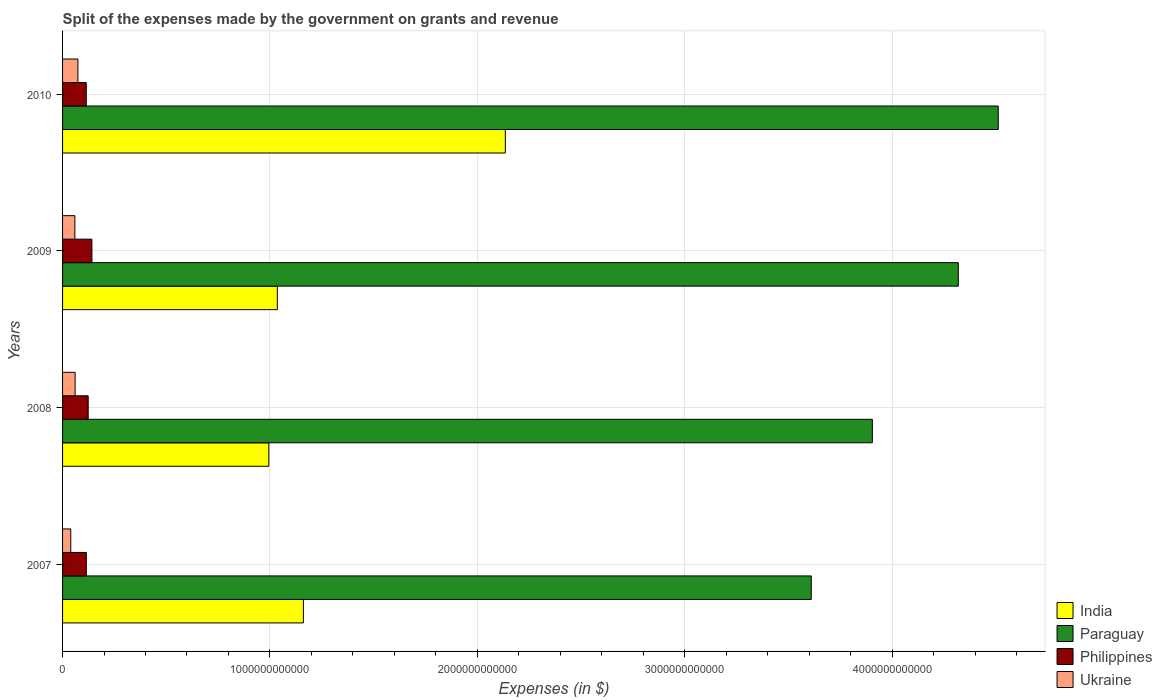How many different coloured bars are there?
Offer a terse response. 4. How many groups of bars are there?
Offer a terse response. 4. Are the number of bars on each tick of the Y-axis equal?
Your response must be concise. Yes. How many bars are there on the 2nd tick from the bottom?
Your answer should be very brief. 4. What is the expenses made by the government on grants and revenue in Paraguay in 2007?
Ensure brevity in your answer.  3.61e+12. Across all years, what is the maximum expenses made by the government on grants and revenue in Philippines?
Your response must be concise. 1.42e+11. Across all years, what is the minimum expenses made by the government on grants and revenue in Paraguay?
Give a very brief answer. 3.61e+12. What is the total expenses made by the government on grants and revenue in Paraguay in the graph?
Your response must be concise. 1.63e+13. What is the difference between the expenses made by the government on grants and revenue in Paraguay in 2007 and that in 2010?
Provide a succinct answer. -9.02e+11. What is the difference between the expenses made by the government on grants and revenue in Paraguay in 2009 and the expenses made by the government on grants and revenue in Ukraine in 2008?
Provide a succinct answer. 4.26e+12. What is the average expenses made by the government on grants and revenue in Philippines per year?
Offer a terse response. 1.23e+11. In the year 2008, what is the difference between the expenses made by the government on grants and revenue in Philippines and expenses made by the government on grants and revenue in Ukraine?
Your answer should be very brief. 6.30e+1. In how many years, is the expenses made by the government on grants and revenue in India greater than 1400000000000 $?
Your answer should be very brief. 1. What is the ratio of the expenses made by the government on grants and revenue in Ukraine in 2007 to that in 2009?
Your answer should be compact. 0.67. Is the difference between the expenses made by the government on grants and revenue in Philippines in 2007 and 2010 greater than the difference between the expenses made by the government on grants and revenue in Ukraine in 2007 and 2010?
Ensure brevity in your answer.  Yes. What is the difference between the highest and the second highest expenses made by the government on grants and revenue in Paraguay?
Give a very brief answer. 1.93e+11. What is the difference between the highest and the lowest expenses made by the government on grants and revenue in Paraguay?
Offer a terse response. 9.02e+11. Is it the case that in every year, the sum of the expenses made by the government on grants and revenue in Paraguay and expenses made by the government on grants and revenue in Ukraine is greater than the sum of expenses made by the government on grants and revenue in India and expenses made by the government on grants and revenue in Philippines?
Ensure brevity in your answer.  Yes. What does the 4th bar from the bottom in 2007 represents?
Your answer should be compact. Ukraine. Are all the bars in the graph horizontal?
Provide a short and direct response. Yes. How many years are there in the graph?
Ensure brevity in your answer.  4. What is the difference between two consecutive major ticks on the X-axis?
Offer a terse response. 1.00e+12. Are the values on the major ticks of X-axis written in scientific E-notation?
Your answer should be very brief. No. Does the graph contain any zero values?
Provide a succinct answer. No. Does the graph contain grids?
Give a very brief answer. Yes. Where does the legend appear in the graph?
Provide a succinct answer. Bottom right. How many legend labels are there?
Ensure brevity in your answer.  4. How are the legend labels stacked?
Offer a terse response. Vertical. What is the title of the graph?
Your answer should be very brief. Split of the expenses made by the government on grants and revenue. What is the label or title of the X-axis?
Provide a short and direct response. Expenses (in $). What is the Expenses (in $) in India in 2007?
Your answer should be very brief. 1.16e+12. What is the Expenses (in $) in Paraguay in 2007?
Give a very brief answer. 3.61e+12. What is the Expenses (in $) of Philippines in 2007?
Your answer should be very brief. 1.15e+11. What is the Expenses (in $) of Ukraine in 2007?
Your response must be concise. 3.95e+1. What is the Expenses (in $) in India in 2008?
Offer a very short reply. 9.95e+11. What is the Expenses (in $) of Paraguay in 2008?
Your answer should be very brief. 3.91e+12. What is the Expenses (in $) in Philippines in 2008?
Your response must be concise. 1.24e+11. What is the Expenses (in $) of Ukraine in 2008?
Offer a terse response. 6.05e+1. What is the Expenses (in $) of India in 2009?
Give a very brief answer. 1.04e+12. What is the Expenses (in $) in Paraguay in 2009?
Your answer should be compact. 4.32e+12. What is the Expenses (in $) of Philippines in 2009?
Offer a very short reply. 1.42e+11. What is the Expenses (in $) of Ukraine in 2009?
Provide a succinct answer. 5.94e+1. What is the Expenses (in $) of India in 2010?
Provide a short and direct response. 2.14e+12. What is the Expenses (in $) in Paraguay in 2010?
Your answer should be compact. 4.51e+12. What is the Expenses (in $) in Philippines in 2010?
Your answer should be compact. 1.14e+11. What is the Expenses (in $) of Ukraine in 2010?
Your answer should be compact. 7.40e+1. Across all years, what is the maximum Expenses (in $) in India?
Your answer should be very brief. 2.14e+12. Across all years, what is the maximum Expenses (in $) in Paraguay?
Give a very brief answer. 4.51e+12. Across all years, what is the maximum Expenses (in $) in Philippines?
Offer a terse response. 1.42e+11. Across all years, what is the maximum Expenses (in $) in Ukraine?
Your answer should be very brief. 7.40e+1. Across all years, what is the minimum Expenses (in $) in India?
Make the answer very short. 9.95e+11. Across all years, what is the minimum Expenses (in $) in Paraguay?
Give a very brief answer. 3.61e+12. Across all years, what is the minimum Expenses (in $) of Philippines?
Make the answer very short. 1.14e+11. Across all years, what is the minimum Expenses (in $) in Ukraine?
Ensure brevity in your answer.  3.95e+1. What is the total Expenses (in $) in India in the graph?
Your answer should be compact. 5.33e+12. What is the total Expenses (in $) in Paraguay in the graph?
Your answer should be very brief. 1.63e+13. What is the total Expenses (in $) of Philippines in the graph?
Offer a terse response. 4.94e+11. What is the total Expenses (in $) of Ukraine in the graph?
Your answer should be very brief. 2.33e+11. What is the difference between the Expenses (in $) of India in 2007 and that in 2008?
Your answer should be compact. 1.67e+11. What is the difference between the Expenses (in $) in Paraguay in 2007 and that in 2008?
Give a very brief answer. -2.95e+11. What is the difference between the Expenses (in $) of Philippines in 2007 and that in 2008?
Give a very brief answer. -9.00e+09. What is the difference between the Expenses (in $) in Ukraine in 2007 and that in 2008?
Give a very brief answer. -2.10e+1. What is the difference between the Expenses (in $) in India in 2007 and that in 2009?
Give a very brief answer. 1.26e+11. What is the difference between the Expenses (in $) in Paraguay in 2007 and that in 2009?
Your answer should be very brief. -7.09e+11. What is the difference between the Expenses (in $) in Philippines in 2007 and that in 2009?
Give a very brief answer. -2.69e+1. What is the difference between the Expenses (in $) of Ukraine in 2007 and that in 2009?
Keep it short and to the point. -1.98e+1. What is the difference between the Expenses (in $) in India in 2007 and that in 2010?
Provide a succinct answer. -9.74e+11. What is the difference between the Expenses (in $) in Paraguay in 2007 and that in 2010?
Ensure brevity in your answer.  -9.02e+11. What is the difference between the Expenses (in $) of Philippines in 2007 and that in 2010?
Give a very brief answer. 2.58e+08. What is the difference between the Expenses (in $) of Ukraine in 2007 and that in 2010?
Offer a very short reply. -3.45e+1. What is the difference between the Expenses (in $) in India in 2008 and that in 2009?
Offer a terse response. -4.10e+1. What is the difference between the Expenses (in $) in Paraguay in 2008 and that in 2009?
Your answer should be very brief. -4.14e+11. What is the difference between the Expenses (in $) of Philippines in 2008 and that in 2009?
Your answer should be very brief. -1.79e+1. What is the difference between the Expenses (in $) in Ukraine in 2008 and that in 2009?
Provide a succinct answer. 1.17e+09. What is the difference between the Expenses (in $) in India in 2008 and that in 2010?
Provide a short and direct response. -1.14e+12. What is the difference between the Expenses (in $) of Paraguay in 2008 and that in 2010?
Your answer should be compact. -6.07e+11. What is the difference between the Expenses (in $) of Philippines in 2008 and that in 2010?
Offer a terse response. 9.26e+09. What is the difference between the Expenses (in $) in Ukraine in 2008 and that in 2010?
Make the answer very short. -1.35e+1. What is the difference between the Expenses (in $) in India in 2009 and that in 2010?
Offer a terse response. -1.10e+12. What is the difference between the Expenses (in $) in Paraguay in 2009 and that in 2010?
Make the answer very short. -1.93e+11. What is the difference between the Expenses (in $) in Philippines in 2009 and that in 2010?
Provide a succinct answer. 2.72e+1. What is the difference between the Expenses (in $) of Ukraine in 2009 and that in 2010?
Ensure brevity in your answer.  -1.47e+1. What is the difference between the Expenses (in $) of India in 2007 and the Expenses (in $) of Paraguay in 2008?
Make the answer very short. -2.74e+12. What is the difference between the Expenses (in $) of India in 2007 and the Expenses (in $) of Philippines in 2008?
Your answer should be compact. 1.04e+12. What is the difference between the Expenses (in $) in India in 2007 and the Expenses (in $) in Ukraine in 2008?
Provide a succinct answer. 1.10e+12. What is the difference between the Expenses (in $) in Paraguay in 2007 and the Expenses (in $) in Philippines in 2008?
Provide a short and direct response. 3.49e+12. What is the difference between the Expenses (in $) in Paraguay in 2007 and the Expenses (in $) in Ukraine in 2008?
Your response must be concise. 3.55e+12. What is the difference between the Expenses (in $) of Philippines in 2007 and the Expenses (in $) of Ukraine in 2008?
Make the answer very short. 5.40e+1. What is the difference between the Expenses (in $) in India in 2007 and the Expenses (in $) in Paraguay in 2009?
Make the answer very short. -3.16e+12. What is the difference between the Expenses (in $) in India in 2007 and the Expenses (in $) in Philippines in 2009?
Offer a terse response. 1.02e+12. What is the difference between the Expenses (in $) in India in 2007 and the Expenses (in $) in Ukraine in 2009?
Ensure brevity in your answer.  1.10e+12. What is the difference between the Expenses (in $) of Paraguay in 2007 and the Expenses (in $) of Philippines in 2009?
Your answer should be compact. 3.47e+12. What is the difference between the Expenses (in $) of Paraguay in 2007 and the Expenses (in $) of Ukraine in 2009?
Your answer should be compact. 3.55e+12. What is the difference between the Expenses (in $) of Philippines in 2007 and the Expenses (in $) of Ukraine in 2009?
Your answer should be compact. 5.52e+1. What is the difference between the Expenses (in $) of India in 2007 and the Expenses (in $) of Paraguay in 2010?
Make the answer very short. -3.35e+12. What is the difference between the Expenses (in $) of India in 2007 and the Expenses (in $) of Philippines in 2010?
Keep it short and to the point. 1.05e+12. What is the difference between the Expenses (in $) in India in 2007 and the Expenses (in $) in Ukraine in 2010?
Your response must be concise. 1.09e+12. What is the difference between the Expenses (in $) of Paraguay in 2007 and the Expenses (in $) of Philippines in 2010?
Give a very brief answer. 3.50e+12. What is the difference between the Expenses (in $) of Paraguay in 2007 and the Expenses (in $) of Ukraine in 2010?
Your answer should be very brief. 3.54e+12. What is the difference between the Expenses (in $) of Philippines in 2007 and the Expenses (in $) of Ukraine in 2010?
Your answer should be compact. 4.05e+1. What is the difference between the Expenses (in $) of India in 2008 and the Expenses (in $) of Paraguay in 2009?
Ensure brevity in your answer.  -3.32e+12. What is the difference between the Expenses (in $) in India in 2008 and the Expenses (in $) in Philippines in 2009?
Your answer should be compact. 8.53e+11. What is the difference between the Expenses (in $) of India in 2008 and the Expenses (in $) of Ukraine in 2009?
Your answer should be compact. 9.35e+11. What is the difference between the Expenses (in $) of Paraguay in 2008 and the Expenses (in $) of Philippines in 2009?
Offer a terse response. 3.76e+12. What is the difference between the Expenses (in $) in Paraguay in 2008 and the Expenses (in $) in Ukraine in 2009?
Provide a short and direct response. 3.85e+12. What is the difference between the Expenses (in $) of Philippines in 2008 and the Expenses (in $) of Ukraine in 2009?
Your answer should be compact. 6.42e+1. What is the difference between the Expenses (in $) of India in 2008 and the Expenses (in $) of Paraguay in 2010?
Keep it short and to the point. -3.52e+12. What is the difference between the Expenses (in $) in India in 2008 and the Expenses (in $) in Philippines in 2010?
Ensure brevity in your answer.  8.80e+11. What is the difference between the Expenses (in $) of India in 2008 and the Expenses (in $) of Ukraine in 2010?
Keep it short and to the point. 9.21e+11. What is the difference between the Expenses (in $) of Paraguay in 2008 and the Expenses (in $) of Philippines in 2010?
Your answer should be compact. 3.79e+12. What is the difference between the Expenses (in $) of Paraguay in 2008 and the Expenses (in $) of Ukraine in 2010?
Make the answer very short. 3.83e+12. What is the difference between the Expenses (in $) in Philippines in 2008 and the Expenses (in $) in Ukraine in 2010?
Offer a terse response. 4.95e+1. What is the difference between the Expenses (in $) of India in 2009 and the Expenses (in $) of Paraguay in 2010?
Provide a short and direct response. -3.48e+12. What is the difference between the Expenses (in $) of India in 2009 and the Expenses (in $) of Philippines in 2010?
Give a very brief answer. 9.21e+11. What is the difference between the Expenses (in $) in India in 2009 and the Expenses (in $) in Ukraine in 2010?
Provide a succinct answer. 9.62e+11. What is the difference between the Expenses (in $) in Paraguay in 2009 and the Expenses (in $) in Philippines in 2010?
Your answer should be compact. 4.21e+12. What is the difference between the Expenses (in $) of Paraguay in 2009 and the Expenses (in $) of Ukraine in 2010?
Provide a succinct answer. 4.25e+12. What is the difference between the Expenses (in $) of Philippines in 2009 and the Expenses (in $) of Ukraine in 2010?
Give a very brief answer. 6.75e+1. What is the average Expenses (in $) of India per year?
Offer a very short reply. 1.33e+12. What is the average Expenses (in $) of Paraguay per year?
Offer a terse response. 4.09e+12. What is the average Expenses (in $) of Philippines per year?
Provide a succinct answer. 1.23e+11. What is the average Expenses (in $) of Ukraine per year?
Give a very brief answer. 5.84e+1. In the year 2007, what is the difference between the Expenses (in $) of India and Expenses (in $) of Paraguay?
Keep it short and to the point. -2.45e+12. In the year 2007, what is the difference between the Expenses (in $) of India and Expenses (in $) of Philippines?
Ensure brevity in your answer.  1.05e+12. In the year 2007, what is the difference between the Expenses (in $) in India and Expenses (in $) in Ukraine?
Make the answer very short. 1.12e+12. In the year 2007, what is the difference between the Expenses (in $) of Paraguay and Expenses (in $) of Philippines?
Offer a terse response. 3.50e+12. In the year 2007, what is the difference between the Expenses (in $) of Paraguay and Expenses (in $) of Ukraine?
Provide a succinct answer. 3.57e+12. In the year 2007, what is the difference between the Expenses (in $) in Philippines and Expenses (in $) in Ukraine?
Your answer should be compact. 7.50e+1. In the year 2008, what is the difference between the Expenses (in $) in India and Expenses (in $) in Paraguay?
Give a very brief answer. -2.91e+12. In the year 2008, what is the difference between the Expenses (in $) of India and Expenses (in $) of Philippines?
Make the answer very short. 8.71e+11. In the year 2008, what is the difference between the Expenses (in $) of India and Expenses (in $) of Ukraine?
Your response must be concise. 9.34e+11. In the year 2008, what is the difference between the Expenses (in $) of Paraguay and Expenses (in $) of Philippines?
Ensure brevity in your answer.  3.78e+12. In the year 2008, what is the difference between the Expenses (in $) of Paraguay and Expenses (in $) of Ukraine?
Your answer should be compact. 3.84e+12. In the year 2008, what is the difference between the Expenses (in $) in Philippines and Expenses (in $) in Ukraine?
Give a very brief answer. 6.30e+1. In the year 2009, what is the difference between the Expenses (in $) of India and Expenses (in $) of Paraguay?
Offer a terse response. -3.28e+12. In the year 2009, what is the difference between the Expenses (in $) in India and Expenses (in $) in Philippines?
Your response must be concise. 8.94e+11. In the year 2009, what is the difference between the Expenses (in $) of India and Expenses (in $) of Ukraine?
Provide a short and direct response. 9.76e+11. In the year 2009, what is the difference between the Expenses (in $) in Paraguay and Expenses (in $) in Philippines?
Make the answer very short. 4.18e+12. In the year 2009, what is the difference between the Expenses (in $) of Paraguay and Expenses (in $) of Ukraine?
Offer a terse response. 4.26e+12. In the year 2009, what is the difference between the Expenses (in $) in Philippines and Expenses (in $) in Ukraine?
Your answer should be compact. 8.21e+1. In the year 2010, what is the difference between the Expenses (in $) in India and Expenses (in $) in Paraguay?
Offer a very short reply. -2.38e+12. In the year 2010, what is the difference between the Expenses (in $) of India and Expenses (in $) of Philippines?
Offer a very short reply. 2.02e+12. In the year 2010, what is the difference between the Expenses (in $) of India and Expenses (in $) of Ukraine?
Provide a short and direct response. 2.06e+12. In the year 2010, what is the difference between the Expenses (in $) of Paraguay and Expenses (in $) of Philippines?
Offer a terse response. 4.40e+12. In the year 2010, what is the difference between the Expenses (in $) in Paraguay and Expenses (in $) in Ukraine?
Make the answer very short. 4.44e+12. In the year 2010, what is the difference between the Expenses (in $) in Philippines and Expenses (in $) in Ukraine?
Your answer should be very brief. 4.03e+1. What is the ratio of the Expenses (in $) of India in 2007 to that in 2008?
Provide a succinct answer. 1.17. What is the ratio of the Expenses (in $) of Paraguay in 2007 to that in 2008?
Offer a very short reply. 0.92. What is the ratio of the Expenses (in $) in Philippines in 2007 to that in 2008?
Offer a terse response. 0.93. What is the ratio of the Expenses (in $) of Ukraine in 2007 to that in 2008?
Make the answer very short. 0.65. What is the ratio of the Expenses (in $) of India in 2007 to that in 2009?
Offer a terse response. 1.12. What is the ratio of the Expenses (in $) in Paraguay in 2007 to that in 2009?
Ensure brevity in your answer.  0.84. What is the ratio of the Expenses (in $) of Philippines in 2007 to that in 2009?
Provide a short and direct response. 0.81. What is the ratio of the Expenses (in $) in Ukraine in 2007 to that in 2009?
Your answer should be compact. 0.67. What is the ratio of the Expenses (in $) of India in 2007 to that in 2010?
Ensure brevity in your answer.  0.54. What is the ratio of the Expenses (in $) in Paraguay in 2007 to that in 2010?
Ensure brevity in your answer.  0.8. What is the ratio of the Expenses (in $) of Ukraine in 2007 to that in 2010?
Make the answer very short. 0.53. What is the ratio of the Expenses (in $) of India in 2008 to that in 2009?
Offer a very short reply. 0.96. What is the ratio of the Expenses (in $) in Paraguay in 2008 to that in 2009?
Ensure brevity in your answer.  0.9. What is the ratio of the Expenses (in $) in Philippines in 2008 to that in 2009?
Offer a very short reply. 0.87. What is the ratio of the Expenses (in $) in Ukraine in 2008 to that in 2009?
Keep it short and to the point. 1.02. What is the ratio of the Expenses (in $) of India in 2008 to that in 2010?
Give a very brief answer. 0.47. What is the ratio of the Expenses (in $) in Paraguay in 2008 to that in 2010?
Your answer should be very brief. 0.87. What is the ratio of the Expenses (in $) of Philippines in 2008 to that in 2010?
Provide a short and direct response. 1.08. What is the ratio of the Expenses (in $) in Ukraine in 2008 to that in 2010?
Your response must be concise. 0.82. What is the ratio of the Expenses (in $) in India in 2009 to that in 2010?
Give a very brief answer. 0.48. What is the ratio of the Expenses (in $) in Paraguay in 2009 to that in 2010?
Provide a succinct answer. 0.96. What is the ratio of the Expenses (in $) in Philippines in 2009 to that in 2010?
Your answer should be very brief. 1.24. What is the ratio of the Expenses (in $) of Ukraine in 2009 to that in 2010?
Your answer should be very brief. 0.8. What is the difference between the highest and the second highest Expenses (in $) of India?
Provide a short and direct response. 9.74e+11. What is the difference between the highest and the second highest Expenses (in $) of Paraguay?
Your answer should be compact. 1.93e+11. What is the difference between the highest and the second highest Expenses (in $) of Philippines?
Give a very brief answer. 1.79e+1. What is the difference between the highest and the second highest Expenses (in $) in Ukraine?
Make the answer very short. 1.35e+1. What is the difference between the highest and the lowest Expenses (in $) in India?
Your answer should be very brief. 1.14e+12. What is the difference between the highest and the lowest Expenses (in $) in Paraguay?
Offer a terse response. 9.02e+11. What is the difference between the highest and the lowest Expenses (in $) in Philippines?
Keep it short and to the point. 2.72e+1. What is the difference between the highest and the lowest Expenses (in $) in Ukraine?
Make the answer very short. 3.45e+1. 